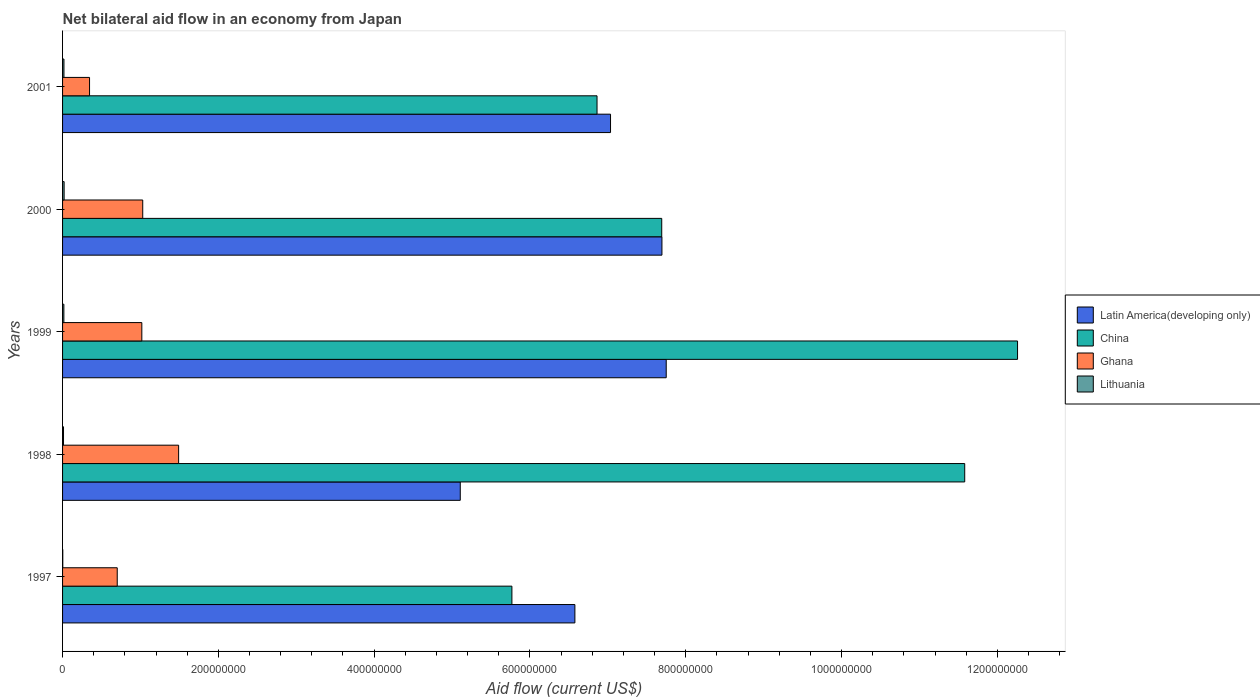How many groups of bars are there?
Provide a short and direct response. 5. Are the number of bars per tick equal to the number of legend labels?
Provide a succinct answer. Yes. Are the number of bars on each tick of the Y-axis equal?
Ensure brevity in your answer.  Yes. How many bars are there on the 4th tick from the bottom?
Your answer should be compact. 4. What is the net bilateral aid flow in Lithuania in 2000?
Provide a short and direct response. 2.01e+06. Across all years, what is the maximum net bilateral aid flow in Ghana?
Give a very brief answer. 1.49e+08. What is the total net bilateral aid flow in Lithuania in the graph?
Offer a very short reply. 6.97e+06. What is the difference between the net bilateral aid flow in Ghana in 1997 and that in 1998?
Your response must be concise. -7.88e+07. What is the difference between the net bilateral aid flow in Latin America(developing only) in 1997 and the net bilateral aid flow in Lithuania in 1999?
Offer a very short reply. 6.56e+08. What is the average net bilateral aid flow in Latin America(developing only) per year?
Keep it short and to the point. 6.83e+08. In the year 1999, what is the difference between the net bilateral aid flow in Ghana and net bilateral aid flow in China?
Keep it short and to the point. -1.12e+09. In how many years, is the net bilateral aid flow in China greater than 280000000 US$?
Provide a succinct answer. 5. What is the ratio of the net bilateral aid flow in China in 1999 to that in 2001?
Offer a terse response. 1.79. Is the net bilateral aid flow in Latin America(developing only) in 1999 less than that in 2001?
Ensure brevity in your answer.  No. What is the difference between the highest and the second highest net bilateral aid flow in Ghana?
Offer a terse response. 4.61e+07. What is the difference between the highest and the lowest net bilateral aid flow in Latin America(developing only)?
Your answer should be compact. 2.64e+08. In how many years, is the net bilateral aid flow in Lithuania greater than the average net bilateral aid flow in Lithuania taken over all years?
Make the answer very short. 3. What does the 3rd bar from the top in 1997 represents?
Your answer should be compact. China. What does the 4th bar from the bottom in 1997 represents?
Ensure brevity in your answer.  Lithuania. Is it the case that in every year, the sum of the net bilateral aid flow in Lithuania and net bilateral aid flow in Latin America(developing only) is greater than the net bilateral aid flow in China?
Provide a short and direct response. No. Are all the bars in the graph horizontal?
Give a very brief answer. Yes. How many years are there in the graph?
Your answer should be very brief. 5. Does the graph contain any zero values?
Provide a short and direct response. No. Where does the legend appear in the graph?
Give a very brief answer. Center right. How are the legend labels stacked?
Keep it short and to the point. Vertical. What is the title of the graph?
Your response must be concise. Net bilateral aid flow in an economy from Japan. What is the label or title of the X-axis?
Your answer should be very brief. Aid flow (current US$). What is the Aid flow (current US$) in Latin America(developing only) in 1997?
Give a very brief answer. 6.58e+08. What is the Aid flow (current US$) in China in 1997?
Provide a succinct answer. 5.77e+08. What is the Aid flow (current US$) of Ghana in 1997?
Ensure brevity in your answer.  7.02e+07. What is the Aid flow (current US$) in Latin America(developing only) in 1998?
Keep it short and to the point. 5.11e+08. What is the Aid flow (current US$) in China in 1998?
Keep it short and to the point. 1.16e+09. What is the Aid flow (current US$) of Ghana in 1998?
Offer a very short reply. 1.49e+08. What is the Aid flow (current US$) of Lithuania in 1998?
Provide a succinct answer. 1.21e+06. What is the Aid flow (current US$) in Latin America(developing only) in 1999?
Your answer should be very brief. 7.75e+08. What is the Aid flow (current US$) of China in 1999?
Your response must be concise. 1.23e+09. What is the Aid flow (current US$) of Ghana in 1999?
Your answer should be compact. 1.02e+08. What is the Aid flow (current US$) in Lithuania in 1999?
Ensure brevity in your answer.  1.69e+06. What is the Aid flow (current US$) of Latin America(developing only) in 2000?
Ensure brevity in your answer.  7.69e+08. What is the Aid flow (current US$) in China in 2000?
Give a very brief answer. 7.69e+08. What is the Aid flow (current US$) of Ghana in 2000?
Make the answer very short. 1.03e+08. What is the Aid flow (current US$) of Lithuania in 2000?
Offer a very short reply. 2.01e+06. What is the Aid flow (current US$) in Latin America(developing only) in 2001?
Give a very brief answer. 7.03e+08. What is the Aid flow (current US$) in China in 2001?
Offer a terse response. 6.86e+08. What is the Aid flow (current US$) in Ghana in 2001?
Offer a very short reply. 3.46e+07. What is the Aid flow (current US$) in Lithuania in 2001?
Give a very brief answer. 1.79e+06. Across all years, what is the maximum Aid flow (current US$) in Latin America(developing only)?
Give a very brief answer. 7.75e+08. Across all years, what is the maximum Aid flow (current US$) of China?
Keep it short and to the point. 1.23e+09. Across all years, what is the maximum Aid flow (current US$) of Ghana?
Provide a succinct answer. 1.49e+08. Across all years, what is the maximum Aid flow (current US$) in Lithuania?
Keep it short and to the point. 2.01e+06. Across all years, what is the minimum Aid flow (current US$) in Latin America(developing only)?
Give a very brief answer. 5.11e+08. Across all years, what is the minimum Aid flow (current US$) in China?
Ensure brevity in your answer.  5.77e+08. Across all years, what is the minimum Aid flow (current US$) of Ghana?
Your answer should be very brief. 3.46e+07. What is the total Aid flow (current US$) of Latin America(developing only) in the graph?
Keep it short and to the point. 3.42e+09. What is the total Aid flow (current US$) in China in the graph?
Ensure brevity in your answer.  4.42e+09. What is the total Aid flow (current US$) in Ghana in the graph?
Keep it short and to the point. 4.58e+08. What is the total Aid flow (current US$) in Lithuania in the graph?
Provide a succinct answer. 6.97e+06. What is the difference between the Aid flow (current US$) in Latin America(developing only) in 1997 and that in 1998?
Your answer should be very brief. 1.47e+08. What is the difference between the Aid flow (current US$) of China in 1997 and that in 1998?
Make the answer very short. -5.81e+08. What is the difference between the Aid flow (current US$) in Ghana in 1997 and that in 1998?
Ensure brevity in your answer.  -7.88e+07. What is the difference between the Aid flow (current US$) in Lithuania in 1997 and that in 1998?
Offer a terse response. -9.40e+05. What is the difference between the Aid flow (current US$) in Latin America(developing only) in 1997 and that in 1999?
Keep it short and to the point. -1.17e+08. What is the difference between the Aid flow (current US$) of China in 1997 and that in 1999?
Your answer should be very brief. -6.49e+08. What is the difference between the Aid flow (current US$) in Ghana in 1997 and that in 1999?
Your answer should be very brief. -3.16e+07. What is the difference between the Aid flow (current US$) in Lithuania in 1997 and that in 1999?
Your answer should be compact. -1.42e+06. What is the difference between the Aid flow (current US$) in Latin America(developing only) in 1997 and that in 2000?
Provide a succinct answer. -1.12e+08. What is the difference between the Aid flow (current US$) in China in 1997 and that in 2000?
Offer a very short reply. -1.92e+08. What is the difference between the Aid flow (current US$) in Ghana in 1997 and that in 2000?
Provide a succinct answer. -3.27e+07. What is the difference between the Aid flow (current US$) in Lithuania in 1997 and that in 2000?
Offer a terse response. -1.74e+06. What is the difference between the Aid flow (current US$) of Latin America(developing only) in 1997 and that in 2001?
Provide a succinct answer. -4.58e+07. What is the difference between the Aid flow (current US$) of China in 1997 and that in 2001?
Your answer should be compact. -1.09e+08. What is the difference between the Aid flow (current US$) in Ghana in 1997 and that in 2001?
Your answer should be compact. 3.56e+07. What is the difference between the Aid flow (current US$) of Lithuania in 1997 and that in 2001?
Give a very brief answer. -1.52e+06. What is the difference between the Aid flow (current US$) of Latin America(developing only) in 1998 and that in 1999?
Ensure brevity in your answer.  -2.64e+08. What is the difference between the Aid flow (current US$) of China in 1998 and that in 1999?
Your response must be concise. -6.78e+07. What is the difference between the Aid flow (current US$) in Ghana in 1998 and that in 1999?
Offer a very short reply. 4.72e+07. What is the difference between the Aid flow (current US$) of Lithuania in 1998 and that in 1999?
Ensure brevity in your answer.  -4.80e+05. What is the difference between the Aid flow (current US$) of Latin America(developing only) in 1998 and that in 2000?
Your answer should be very brief. -2.59e+08. What is the difference between the Aid flow (current US$) of China in 1998 and that in 2000?
Provide a short and direct response. 3.89e+08. What is the difference between the Aid flow (current US$) of Ghana in 1998 and that in 2000?
Provide a succinct answer. 4.61e+07. What is the difference between the Aid flow (current US$) of Lithuania in 1998 and that in 2000?
Offer a very short reply. -8.00e+05. What is the difference between the Aid flow (current US$) in Latin America(developing only) in 1998 and that in 2001?
Provide a succinct answer. -1.93e+08. What is the difference between the Aid flow (current US$) of China in 1998 and that in 2001?
Ensure brevity in your answer.  4.72e+08. What is the difference between the Aid flow (current US$) in Ghana in 1998 and that in 2001?
Provide a succinct answer. 1.14e+08. What is the difference between the Aid flow (current US$) of Lithuania in 1998 and that in 2001?
Provide a short and direct response. -5.80e+05. What is the difference between the Aid flow (current US$) of Latin America(developing only) in 1999 and that in 2000?
Offer a very short reply. 5.51e+06. What is the difference between the Aid flow (current US$) in China in 1999 and that in 2000?
Offer a terse response. 4.57e+08. What is the difference between the Aid flow (current US$) of Ghana in 1999 and that in 2000?
Your response must be concise. -1.16e+06. What is the difference between the Aid flow (current US$) of Lithuania in 1999 and that in 2000?
Offer a very short reply. -3.20e+05. What is the difference between the Aid flow (current US$) of Latin America(developing only) in 1999 and that in 2001?
Keep it short and to the point. 7.15e+07. What is the difference between the Aid flow (current US$) of China in 1999 and that in 2001?
Your answer should be compact. 5.40e+08. What is the difference between the Aid flow (current US$) of Ghana in 1999 and that in 2001?
Provide a short and direct response. 6.71e+07. What is the difference between the Aid flow (current US$) of Lithuania in 1999 and that in 2001?
Offer a terse response. -1.00e+05. What is the difference between the Aid flow (current US$) of Latin America(developing only) in 2000 and that in 2001?
Make the answer very short. 6.60e+07. What is the difference between the Aid flow (current US$) in China in 2000 and that in 2001?
Offer a terse response. 8.31e+07. What is the difference between the Aid flow (current US$) in Ghana in 2000 and that in 2001?
Your answer should be compact. 6.83e+07. What is the difference between the Aid flow (current US$) in Latin America(developing only) in 1997 and the Aid flow (current US$) in China in 1998?
Make the answer very short. -5.00e+08. What is the difference between the Aid flow (current US$) of Latin America(developing only) in 1997 and the Aid flow (current US$) of Ghana in 1998?
Make the answer very short. 5.09e+08. What is the difference between the Aid flow (current US$) of Latin America(developing only) in 1997 and the Aid flow (current US$) of Lithuania in 1998?
Your answer should be very brief. 6.56e+08. What is the difference between the Aid flow (current US$) in China in 1997 and the Aid flow (current US$) in Ghana in 1998?
Your answer should be compact. 4.28e+08. What is the difference between the Aid flow (current US$) in China in 1997 and the Aid flow (current US$) in Lithuania in 1998?
Your answer should be very brief. 5.76e+08. What is the difference between the Aid flow (current US$) of Ghana in 1997 and the Aid flow (current US$) of Lithuania in 1998?
Make the answer very short. 6.90e+07. What is the difference between the Aid flow (current US$) of Latin America(developing only) in 1997 and the Aid flow (current US$) of China in 1999?
Keep it short and to the point. -5.68e+08. What is the difference between the Aid flow (current US$) in Latin America(developing only) in 1997 and the Aid flow (current US$) in Ghana in 1999?
Keep it short and to the point. 5.56e+08. What is the difference between the Aid flow (current US$) in Latin America(developing only) in 1997 and the Aid flow (current US$) in Lithuania in 1999?
Offer a very short reply. 6.56e+08. What is the difference between the Aid flow (current US$) in China in 1997 and the Aid flow (current US$) in Ghana in 1999?
Provide a succinct answer. 4.75e+08. What is the difference between the Aid flow (current US$) of China in 1997 and the Aid flow (current US$) of Lithuania in 1999?
Offer a very short reply. 5.75e+08. What is the difference between the Aid flow (current US$) in Ghana in 1997 and the Aid flow (current US$) in Lithuania in 1999?
Your response must be concise. 6.85e+07. What is the difference between the Aid flow (current US$) in Latin America(developing only) in 1997 and the Aid flow (current US$) in China in 2000?
Make the answer very short. -1.11e+08. What is the difference between the Aid flow (current US$) in Latin America(developing only) in 1997 and the Aid flow (current US$) in Ghana in 2000?
Your answer should be compact. 5.55e+08. What is the difference between the Aid flow (current US$) in Latin America(developing only) in 1997 and the Aid flow (current US$) in Lithuania in 2000?
Provide a succinct answer. 6.56e+08. What is the difference between the Aid flow (current US$) of China in 1997 and the Aid flow (current US$) of Ghana in 2000?
Your answer should be compact. 4.74e+08. What is the difference between the Aid flow (current US$) of China in 1997 and the Aid flow (current US$) of Lithuania in 2000?
Make the answer very short. 5.75e+08. What is the difference between the Aid flow (current US$) of Ghana in 1997 and the Aid flow (current US$) of Lithuania in 2000?
Provide a short and direct response. 6.82e+07. What is the difference between the Aid flow (current US$) in Latin America(developing only) in 1997 and the Aid flow (current US$) in China in 2001?
Offer a terse response. -2.84e+07. What is the difference between the Aid flow (current US$) in Latin America(developing only) in 1997 and the Aid flow (current US$) in Ghana in 2001?
Provide a short and direct response. 6.23e+08. What is the difference between the Aid flow (current US$) of Latin America(developing only) in 1997 and the Aid flow (current US$) of Lithuania in 2001?
Offer a terse response. 6.56e+08. What is the difference between the Aid flow (current US$) of China in 1997 and the Aid flow (current US$) of Ghana in 2001?
Make the answer very short. 5.42e+08. What is the difference between the Aid flow (current US$) in China in 1997 and the Aid flow (current US$) in Lithuania in 2001?
Offer a very short reply. 5.75e+08. What is the difference between the Aid flow (current US$) of Ghana in 1997 and the Aid flow (current US$) of Lithuania in 2001?
Your answer should be very brief. 6.84e+07. What is the difference between the Aid flow (current US$) of Latin America(developing only) in 1998 and the Aid flow (current US$) of China in 1999?
Offer a terse response. -7.15e+08. What is the difference between the Aid flow (current US$) of Latin America(developing only) in 1998 and the Aid flow (current US$) of Ghana in 1999?
Offer a very short reply. 4.09e+08. What is the difference between the Aid flow (current US$) in Latin America(developing only) in 1998 and the Aid flow (current US$) in Lithuania in 1999?
Offer a very short reply. 5.09e+08. What is the difference between the Aid flow (current US$) in China in 1998 and the Aid flow (current US$) in Ghana in 1999?
Give a very brief answer. 1.06e+09. What is the difference between the Aid flow (current US$) of China in 1998 and the Aid flow (current US$) of Lithuania in 1999?
Offer a terse response. 1.16e+09. What is the difference between the Aid flow (current US$) of Ghana in 1998 and the Aid flow (current US$) of Lithuania in 1999?
Your answer should be very brief. 1.47e+08. What is the difference between the Aid flow (current US$) in Latin America(developing only) in 1998 and the Aid flow (current US$) in China in 2000?
Offer a very short reply. -2.59e+08. What is the difference between the Aid flow (current US$) of Latin America(developing only) in 1998 and the Aid flow (current US$) of Ghana in 2000?
Make the answer very short. 4.08e+08. What is the difference between the Aid flow (current US$) in Latin America(developing only) in 1998 and the Aid flow (current US$) in Lithuania in 2000?
Ensure brevity in your answer.  5.09e+08. What is the difference between the Aid flow (current US$) of China in 1998 and the Aid flow (current US$) of Ghana in 2000?
Provide a succinct answer. 1.06e+09. What is the difference between the Aid flow (current US$) of China in 1998 and the Aid flow (current US$) of Lithuania in 2000?
Your response must be concise. 1.16e+09. What is the difference between the Aid flow (current US$) in Ghana in 1998 and the Aid flow (current US$) in Lithuania in 2000?
Your response must be concise. 1.47e+08. What is the difference between the Aid flow (current US$) in Latin America(developing only) in 1998 and the Aid flow (current US$) in China in 2001?
Offer a very short reply. -1.76e+08. What is the difference between the Aid flow (current US$) in Latin America(developing only) in 1998 and the Aid flow (current US$) in Ghana in 2001?
Offer a very short reply. 4.76e+08. What is the difference between the Aid flow (current US$) of Latin America(developing only) in 1998 and the Aid flow (current US$) of Lithuania in 2001?
Your answer should be compact. 5.09e+08. What is the difference between the Aid flow (current US$) of China in 1998 and the Aid flow (current US$) of Ghana in 2001?
Provide a succinct answer. 1.12e+09. What is the difference between the Aid flow (current US$) in China in 1998 and the Aid flow (current US$) in Lithuania in 2001?
Your response must be concise. 1.16e+09. What is the difference between the Aid flow (current US$) in Ghana in 1998 and the Aid flow (current US$) in Lithuania in 2001?
Make the answer very short. 1.47e+08. What is the difference between the Aid flow (current US$) in Latin America(developing only) in 1999 and the Aid flow (current US$) in China in 2000?
Your answer should be compact. 5.77e+06. What is the difference between the Aid flow (current US$) in Latin America(developing only) in 1999 and the Aid flow (current US$) in Ghana in 2000?
Ensure brevity in your answer.  6.72e+08. What is the difference between the Aid flow (current US$) of Latin America(developing only) in 1999 and the Aid flow (current US$) of Lithuania in 2000?
Give a very brief answer. 7.73e+08. What is the difference between the Aid flow (current US$) in China in 1999 and the Aid flow (current US$) in Ghana in 2000?
Keep it short and to the point. 1.12e+09. What is the difference between the Aid flow (current US$) of China in 1999 and the Aid flow (current US$) of Lithuania in 2000?
Ensure brevity in your answer.  1.22e+09. What is the difference between the Aid flow (current US$) in Ghana in 1999 and the Aid flow (current US$) in Lithuania in 2000?
Give a very brief answer. 9.97e+07. What is the difference between the Aid flow (current US$) of Latin America(developing only) in 1999 and the Aid flow (current US$) of China in 2001?
Offer a terse response. 8.88e+07. What is the difference between the Aid flow (current US$) of Latin America(developing only) in 1999 and the Aid flow (current US$) of Ghana in 2001?
Your response must be concise. 7.40e+08. What is the difference between the Aid flow (current US$) in Latin America(developing only) in 1999 and the Aid flow (current US$) in Lithuania in 2001?
Make the answer very short. 7.73e+08. What is the difference between the Aid flow (current US$) of China in 1999 and the Aid flow (current US$) of Ghana in 2001?
Give a very brief answer. 1.19e+09. What is the difference between the Aid flow (current US$) of China in 1999 and the Aid flow (current US$) of Lithuania in 2001?
Keep it short and to the point. 1.22e+09. What is the difference between the Aid flow (current US$) of Ghana in 1999 and the Aid flow (current US$) of Lithuania in 2001?
Your answer should be very brief. 1.00e+08. What is the difference between the Aid flow (current US$) of Latin America(developing only) in 2000 and the Aid flow (current US$) of China in 2001?
Make the answer very short. 8.33e+07. What is the difference between the Aid flow (current US$) in Latin America(developing only) in 2000 and the Aid flow (current US$) in Ghana in 2001?
Your answer should be very brief. 7.35e+08. What is the difference between the Aid flow (current US$) of Latin America(developing only) in 2000 and the Aid flow (current US$) of Lithuania in 2001?
Keep it short and to the point. 7.68e+08. What is the difference between the Aid flow (current US$) in China in 2000 and the Aid flow (current US$) in Ghana in 2001?
Provide a short and direct response. 7.35e+08. What is the difference between the Aid flow (current US$) of China in 2000 and the Aid flow (current US$) of Lithuania in 2001?
Give a very brief answer. 7.67e+08. What is the difference between the Aid flow (current US$) in Ghana in 2000 and the Aid flow (current US$) in Lithuania in 2001?
Provide a short and direct response. 1.01e+08. What is the average Aid flow (current US$) of Latin America(developing only) per year?
Provide a short and direct response. 6.83e+08. What is the average Aid flow (current US$) in China per year?
Your answer should be compact. 8.83e+08. What is the average Aid flow (current US$) of Ghana per year?
Ensure brevity in your answer.  9.17e+07. What is the average Aid flow (current US$) in Lithuania per year?
Your response must be concise. 1.39e+06. In the year 1997, what is the difference between the Aid flow (current US$) of Latin America(developing only) and Aid flow (current US$) of China?
Your response must be concise. 8.08e+07. In the year 1997, what is the difference between the Aid flow (current US$) in Latin America(developing only) and Aid flow (current US$) in Ghana?
Your response must be concise. 5.88e+08. In the year 1997, what is the difference between the Aid flow (current US$) in Latin America(developing only) and Aid flow (current US$) in Lithuania?
Give a very brief answer. 6.57e+08. In the year 1997, what is the difference between the Aid flow (current US$) in China and Aid flow (current US$) in Ghana?
Keep it short and to the point. 5.07e+08. In the year 1997, what is the difference between the Aid flow (current US$) in China and Aid flow (current US$) in Lithuania?
Offer a very short reply. 5.77e+08. In the year 1997, what is the difference between the Aid flow (current US$) in Ghana and Aid flow (current US$) in Lithuania?
Your answer should be very brief. 6.99e+07. In the year 1998, what is the difference between the Aid flow (current US$) of Latin America(developing only) and Aid flow (current US$) of China?
Your answer should be compact. -6.48e+08. In the year 1998, what is the difference between the Aid flow (current US$) of Latin America(developing only) and Aid flow (current US$) of Ghana?
Ensure brevity in your answer.  3.62e+08. In the year 1998, what is the difference between the Aid flow (current US$) of Latin America(developing only) and Aid flow (current US$) of Lithuania?
Your answer should be compact. 5.09e+08. In the year 1998, what is the difference between the Aid flow (current US$) of China and Aid flow (current US$) of Ghana?
Make the answer very short. 1.01e+09. In the year 1998, what is the difference between the Aid flow (current US$) in China and Aid flow (current US$) in Lithuania?
Make the answer very short. 1.16e+09. In the year 1998, what is the difference between the Aid flow (current US$) in Ghana and Aid flow (current US$) in Lithuania?
Provide a succinct answer. 1.48e+08. In the year 1999, what is the difference between the Aid flow (current US$) of Latin America(developing only) and Aid flow (current US$) of China?
Offer a very short reply. -4.51e+08. In the year 1999, what is the difference between the Aid flow (current US$) of Latin America(developing only) and Aid flow (current US$) of Ghana?
Offer a terse response. 6.73e+08. In the year 1999, what is the difference between the Aid flow (current US$) of Latin America(developing only) and Aid flow (current US$) of Lithuania?
Provide a succinct answer. 7.73e+08. In the year 1999, what is the difference between the Aid flow (current US$) of China and Aid flow (current US$) of Ghana?
Provide a short and direct response. 1.12e+09. In the year 1999, what is the difference between the Aid flow (current US$) of China and Aid flow (current US$) of Lithuania?
Provide a short and direct response. 1.22e+09. In the year 1999, what is the difference between the Aid flow (current US$) in Ghana and Aid flow (current US$) in Lithuania?
Offer a very short reply. 1.00e+08. In the year 2000, what is the difference between the Aid flow (current US$) of Latin America(developing only) and Aid flow (current US$) of China?
Make the answer very short. 2.60e+05. In the year 2000, what is the difference between the Aid flow (current US$) in Latin America(developing only) and Aid flow (current US$) in Ghana?
Your answer should be very brief. 6.67e+08. In the year 2000, what is the difference between the Aid flow (current US$) of Latin America(developing only) and Aid flow (current US$) of Lithuania?
Your answer should be compact. 7.67e+08. In the year 2000, what is the difference between the Aid flow (current US$) of China and Aid flow (current US$) of Ghana?
Your answer should be very brief. 6.66e+08. In the year 2000, what is the difference between the Aid flow (current US$) in China and Aid flow (current US$) in Lithuania?
Give a very brief answer. 7.67e+08. In the year 2000, what is the difference between the Aid flow (current US$) in Ghana and Aid flow (current US$) in Lithuania?
Ensure brevity in your answer.  1.01e+08. In the year 2001, what is the difference between the Aid flow (current US$) in Latin America(developing only) and Aid flow (current US$) in China?
Ensure brevity in your answer.  1.73e+07. In the year 2001, what is the difference between the Aid flow (current US$) of Latin America(developing only) and Aid flow (current US$) of Ghana?
Offer a terse response. 6.69e+08. In the year 2001, what is the difference between the Aid flow (current US$) in Latin America(developing only) and Aid flow (current US$) in Lithuania?
Your answer should be very brief. 7.02e+08. In the year 2001, what is the difference between the Aid flow (current US$) of China and Aid flow (current US$) of Ghana?
Your answer should be compact. 6.52e+08. In the year 2001, what is the difference between the Aid flow (current US$) of China and Aid flow (current US$) of Lithuania?
Provide a short and direct response. 6.84e+08. In the year 2001, what is the difference between the Aid flow (current US$) of Ghana and Aid flow (current US$) of Lithuania?
Make the answer very short. 3.28e+07. What is the ratio of the Aid flow (current US$) in Latin America(developing only) in 1997 to that in 1998?
Provide a short and direct response. 1.29. What is the ratio of the Aid flow (current US$) of China in 1997 to that in 1998?
Make the answer very short. 0.5. What is the ratio of the Aid flow (current US$) of Ghana in 1997 to that in 1998?
Make the answer very short. 0.47. What is the ratio of the Aid flow (current US$) in Lithuania in 1997 to that in 1998?
Keep it short and to the point. 0.22. What is the ratio of the Aid flow (current US$) in Latin America(developing only) in 1997 to that in 1999?
Ensure brevity in your answer.  0.85. What is the ratio of the Aid flow (current US$) in China in 1997 to that in 1999?
Offer a very short reply. 0.47. What is the ratio of the Aid flow (current US$) of Ghana in 1997 to that in 1999?
Your response must be concise. 0.69. What is the ratio of the Aid flow (current US$) of Lithuania in 1997 to that in 1999?
Provide a short and direct response. 0.16. What is the ratio of the Aid flow (current US$) in Latin America(developing only) in 1997 to that in 2000?
Provide a short and direct response. 0.85. What is the ratio of the Aid flow (current US$) in Ghana in 1997 to that in 2000?
Ensure brevity in your answer.  0.68. What is the ratio of the Aid flow (current US$) in Lithuania in 1997 to that in 2000?
Your response must be concise. 0.13. What is the ratio of the Aid flow (current US$) of Latin America(developing only) in 1997 to that in 2001?
Offer a very short reply. 0.94. What is the ratio of the Aid flow (current US$) in China in 1997 to that in 2001?
Your response must be concise. 0.84. What is the ratio of the Aid flow (current US$) of Ghana in 1997 to that in 2001?
Provide a short and direct response. 2.03. What is the ratio of the Aid flow (current US$) of Lithuania in 1997 to that in 2001?
Ensure brevity in your answer.  0.15. What is the ratio of the Aid flow (current US$) of Latin America(developing only) in 1998 to that in 1999?
Your answer should be compact. 0.66. What is the ratio of the Aid flow (current US$) of China in 1998 to that in 1999?
Offer a very short reply. 0.94. What is the ratio of the Aid flow (current US$) of Ghana in 1998 to that in 1999?
Ensure brevity in your answer.  1.46. What is the ratio of the Aid flow (current US$) in Lithuania in 1998 to that in 1999?
Ensure brevity in your answer.  0.72. What is the ratio of the Aid flow (current US$) of Latin America(developing only) in 1998 to that in 2000?
Your answer should be compact. 0.66. What is the ratio of the Aid flow (current US$) in China in 1998 to that in 2000?
Make the answer very short. 1.51. What is the ratio of the Aid flow (current US$) of Ghana in 1998 to that in 2000?
Your answer should be compact. 1.45. What is the ratio of the Aid flow (current US$) in Lithuania in 1998 to that in 2000?
Give a very brief answer. 0.6. What is the ratio of the Aid flow (current US$) of Latin America(developing only) in 1998 to that in 2001?
Offer a terse response. 0.73. What is the ratio of the Aid flow (current US$) in China in 1998 to that in 2001?
Make the answer very short. 1.69. What is the ratio of the Aid flow (current US$) in Ghana in 1998 to that in 2001?
Your answer should be very brief. 4.3. What is the ratio of the Aid flow (current US$) in Lithuania in 1998 to that in 2001?
Offer a very short reply. 0.68. What is the ratio of the Aid flow (current US$) in China in 1999 to that in 2000?
Keep it short and to the point. 1.59. What is the ratio of the Aid flow (current US$) of Ghana in 1999 to that in 2000?
Ensure brevity in your answer.  0.99. What is the ratio of the Aid flow (current US$) in Lithuania in 1999 to that in 2000?
Provide a succinct answer. 0.84. What is the ratio of the Aid flow (current US$) in Latin America(developing only) in 1999 to that in 2001?
Your answer should be very brief. 1.1. What is the ratio of the Aid flow (current US$) in China in 1999 to that in 2001?
Ensure brevity in your answer.  1.79. What is the ratio of the Aid flow (current US$) in Ghana in 1999 to that in 2001?
Make the answer very short. 2.94. What is the ratio of the Aid flow (current US$) in Lithuania in 1999 to that in 2001?
Offer a very short reply. 0.94. What is the ratio of the Aid flow (current US$) of Latin America(developing only) in 2000 to that in 2001?
Provide a short and direct response. 1.09. What is the ratio of the Aid flow (current US$) of China in 2000 to that in 2001?
Provide a short and direct response. 1.12. What is the ratio of the Aid flow (current US$) in Ghana in 2000 to that in 2001?
Offer a very short reply. 2.97. What is the ratio of the Aid flow (current US$) in Lithuania in 2000 to that in 2001?
Ensure brevity in your answer.  1.12. What is the difference between the highest and the second highest Aid flow (current US$) in Latin America(developing only)?
Keep it short and to the point. 5.51e+06. What is the difference between the highest and the second highest Aid flow (current US$) of China?
Your answer should be compact. 6.78e+07. What is the difference between the highest and the second highest Aid flow (current US$) of Ghana?
Your answer should be compact. 4.61e+07. What is the difference between the highest and the lowest Aid flow (current US$) of Latin America(developing only)?
Make the answer very short. 2.64e+08. What is the difference between the highest and the lowest Aid flow (current US$) of China?
Your answer should be compact. 6.49e+08. What is the difference between the highest and the lowest Aid flow (current US$) of Ghana?
Offer a terse response. 1.14e+08. What is the difference between the highest and the lowest Aid flow (current US$) of Lithuania?
Your answer should be compact. 1.74e+06. 